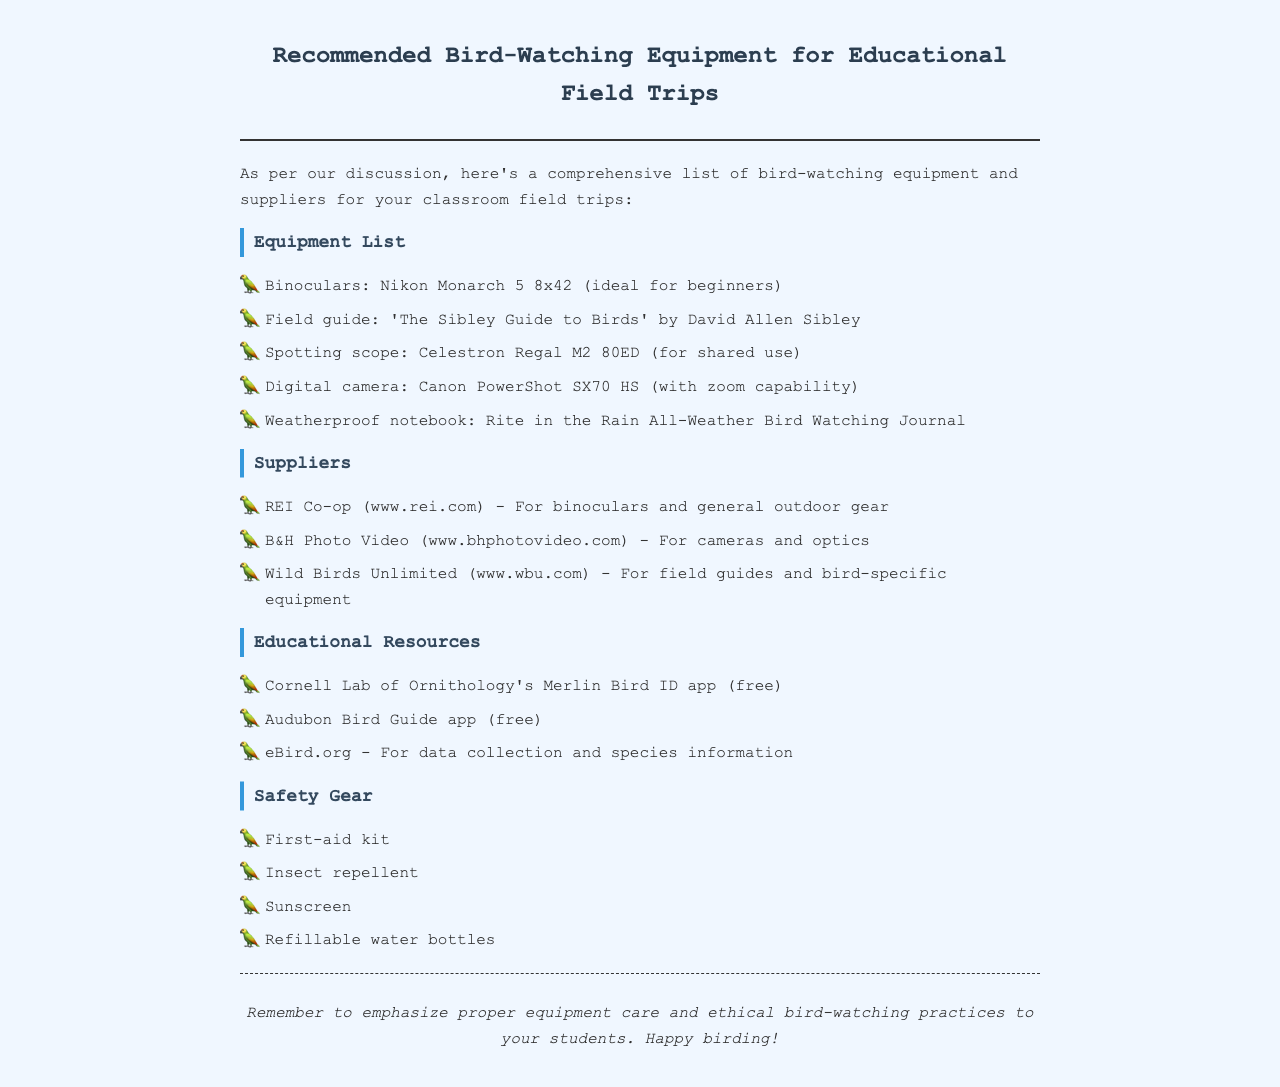What is the title of the document? The title is indicated at the top of the document in the header section.
Answer: Recommended Bird-Watching Equipment for Educational Field Trips Who is the author of the field guide mentioned? The field guide is authored by David Allen Sibley, which is specified in the Equipment List.
Answer: David Allen Sibley What equipment is suggested for shared use? The document lists specific equipment types under the equipment section; the spotting scope is meant for shared use.
Answer: Celestron Regal M2 80ED Which supplier offers general outdoor gear? The suppliers are listed under the Suppliers section; REI Co-op provides general outdoor gear.
Answer: REI Co-op How many educational resources are listed? The educational resources are enumerated in a bulleted list; counting the items gives us the total.
Answer: Three What is included in the Safety Gear section? The Safety Gear section lists specific items that are necessary for safety during field trips.
Answer: First-aid kit What should be emphasized to students according to the footer? The footer provides guidance on what to teach students related to equipment and practices in bird-watching.
Answer: Proper equipment care and ethical bird-watching practices 